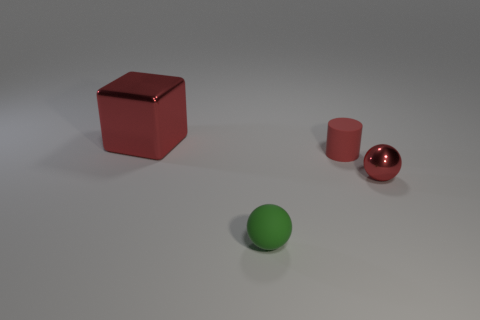What is the size of the red metal cube?
Provide a succinct answer. Large. Are there the same number of small red balls that are behind the red sphere and matte things?
Make the answer very short. No. How many other objects are there of the same color as the matte sphere?
Give a very brief answer. 0. What is the color of the object that is to the left of the tiny red matte cylinder and in front of the big red cube?
Your answer should be compact. Green. What is the size of the metal object that is to the right of the ball in front of the metallic object that is in front of the red shiny cube?
Offer a very short reply. Small. What number of things are tiny balls on the left side of the tiny red rubber cylinder or red things in front of the cube?
Keep it short and to the point. 3. What shape is the small red rubber thing?
Provide a short and direct response. Cylinder. How many other objects are the same material as the tiny cylinder?
Offer a terse response. 1. There is a green matte object that is the same shape as the tiny metal thing; what size is it?
Offer a very short reply. Small. What material is the sphere on the left side of the metallic object that is in front of the red thing that is to the left of the small green rubber thing?
Your answer should be very brief. Rubber. 